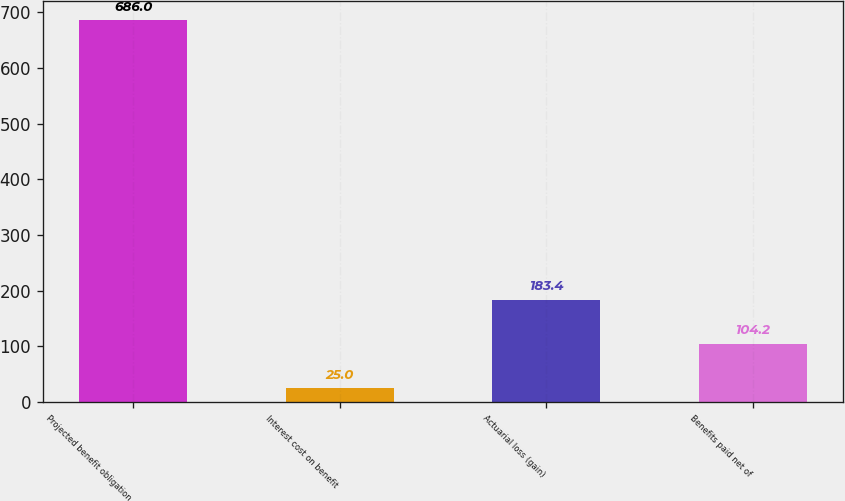Convert chart to OTSL. <chart><loc_0><loc_0><loc_500><loc_500><bar_chart><fcel>Projected benefit obligation<fcel>Interest cost on benefit<fcel>Actuarial loss (gain)<fcel>Benefits paid net of<nl><fcel>686<fcel>25<fcel>183.4<fcel>104.2<nl></chart> 